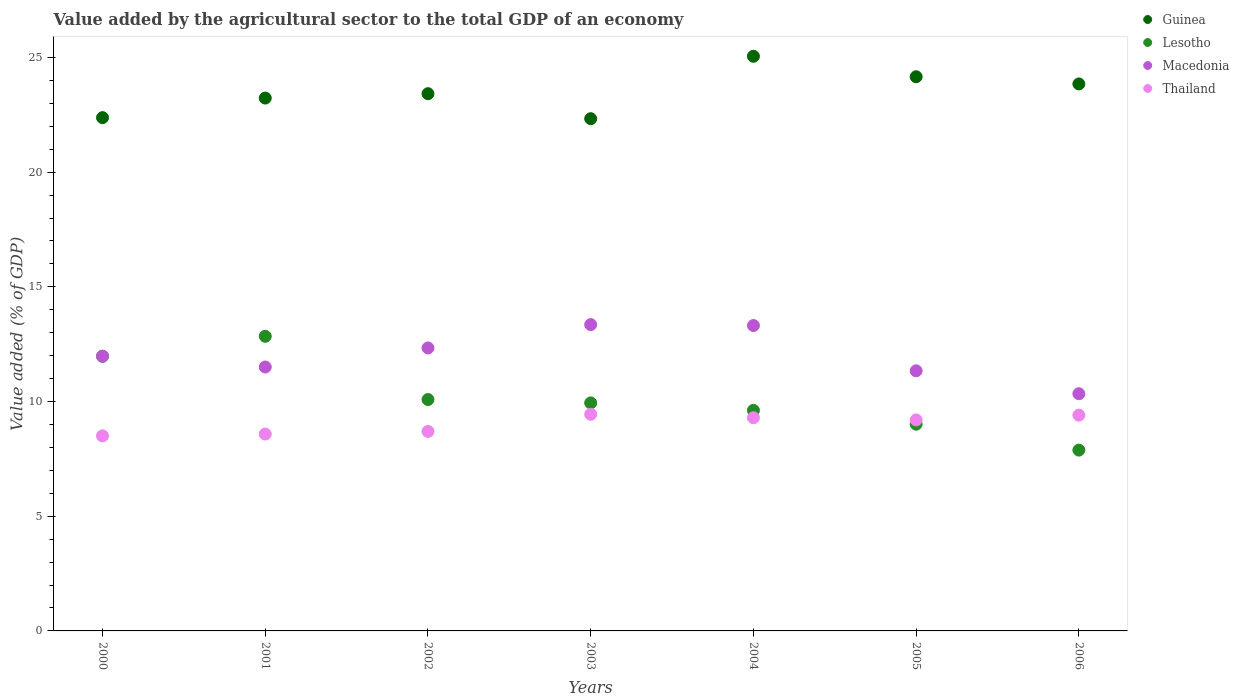What is the value added by the agricultural sector to the total GDP in Guinea in 2001?
Give a very brief answer. 23.23. Across all years, what is the maximum value added by the agricultural sector to the total GDP in Guinea?
Keep it short and to the point. 25.05. Across all years, what is the minimum value added by the agricultural sector to the total GDP in Thailand?
Keep it short and to the point. 8.5. In which year was the value added by the agricultural sector to the total GDP in Thailand maximum?
Provide a succinct answer. 2003. In which year was the value added by the agricultural sector to the total GDP in Macedonia minimum?
Keep it short and to the point. 2006. What is the total value added by the agricultural sector to the total GDP in Guinea in the graph?
Offer a terse response. 164.4. What is the difference between the value added by the agricultural sector to the total GDP in Macedonia in 2005 and that in 2006?
Your response must be concise. 1. What is the difference between the value added by the agricultural sector to the total GDP in Lesotho in 2006 and the value added by the agricultural sector to the total GDP in Macedonia in 2004?
Your answer should be compact. -5.43. What is the average value added by the agricultural sector to the total GDP in Lesotho per year?
Keep it short and to the point. 10.19. In the year 2000, what is the difference between the value added by the agricultural sector to the total GDP in Macedonia and value added by the agricultural sector to the total GDP in Thailand?
Ensure brevity in your answer.  3.47. In how many years, is the value added by the agricultural sector to the total GDP in Guinea greater than 2 %?
Your response must be concise. 7. What is the ratio of the value added by the agricultural sector to the total GDP in Thailand in 2002 to that in 2003?
Your response must be concise. 0.92. What is the difference between the highest and the second highest value added by the agricultural sector to the total GDP in Lesotho?
Make the answer very short. 0.87. What is the difference between the highest and the lowest value added by the agricultural sector to the total GDP in Lesotho?
Give a very brief answer. 4.96. Is the sum of the value added by the agricultural sector to the total GDP in Macedonia in 2001 and 2002 greater than the maximum value added by the agricultural sector to the total GDP in Guinea across all years?
Your answer should be compact. No. Is it the case that in every year, the sum of the value added by the agricultural sector to the total GDP in Macedonia and value added by the agricultural sector to the total GDP in Thailand  is greater than the sum of value added by the agricultural sector to the total GDP in Lesotho and value added by the agricultural sector to the total GDP in Guinea?
Make the answer very short. Yes. Is the value added by the agricultural sector to the total GDP in Macedonia strictly less than the value added by the agricultural sector to the total GDP in Guinea over the years?
Your answer should be very brief. Yes. How many dotlines are there?
Your answer should be very brief. 4. What is the difference between two consecutive major ticks on the Y-axis?
Give a very brief answer. 5. Does the graph contain any zero values?
Make the answer very short. No. Does the graph contain grids?
Give a very brief answer. No. Where does the legend appear in the graph?
Your answer should be very brief. Top right. How many legend labels are there?
Give a very brief answer. 4. What is the title of the graph?
Your answer should be very brief. Value added by the agricultural sector to the total GDP of an economy. Does "Ethiopia" appear as one of the legend labels in the graph?
Ensure brevity in your answer.  No. What is the label or title of the X-axis?
Offer a terse response. Years. What is the label or title of the Y-axis?
Give a very brief answer. Value added (% of GDP). What is the Value added (% of GDP) of Guinea in 2000?
Ensure brevity in your answer.  22.38. What is the Value added (% of GDP) of Lesotho in 2000?
Provide a succinct answer. 11.97. What is the Value added (% of GDP) of Macedonia in 2000?
Your answer should be very brief. 11.98. What is the Value added (% of GDP) of Thailand in 2000?
Provide a succinct answer. 8.5. What is the Value added (% of GDP) of Guinea in 2001?
Ensure brevity in your answer.  23.23. What is the Value added (% of GDP) in Lesotho in 2001?
Make the answer very short. 12.84. What is the Value added (% of GDP) in Macedonia in 2001?
Your response must be concise. 11.5. What is the Value added (% of GDP) of Thailand in 2001?
Ensure brevity in your answer.  8.58. What is the Value added (% of GDP) of Guinea in 2002?
Your answer should be compact. 23.42. What is the Value added (% of GDP) in Lesotho in 2002?
Your answer should be compact. 10.09. What is the Value added (% of GDP) in Macedonia in 2002?
Offer a terse response. 12.34. What is the Value added (% of GDP) in Thailand in 2002?
Offer a terse response. 8.7. What is the Value added (% of GDP) of Guinea in 2003?
Ensure brevity in your answer.  22.33. What is the Value added (% of GDP) in Lesotho in 2003?
Ensure brevity in your answer.  9.94. What is the Value added (% of GDP) of Macedonia in 2003?
Keep it short and to the point. 13.35. What is the Value added (% of GDP) in Thailand in 2003?
Provide a short and direct response. 9.44. What is the Value added (% of GDP) in Guinea in 2004?
Your answer should be very brief. 25.05. What is the Value added (% of GDP) of Lesotho in 2004?
Ensure brevity in your answer.  9.62. What is the Value added (% of GDP) in Macedonia in 2004?
Your answer should be compact. 13.31. What is the Value added (% of GDP) of Thailand in 2004?
Give a very brief answer. 9.29. What is the Value added (% of GDP) in Guinea in 2005?
Ensure brevity in your answer.  24.16. What is the Value added (% of GDP) of Lesotho in 2005?
Provide a short and direct response. 9.01. What is the Value added (% of GDP) in Macedonia in 2005?
Offer a very short reply. 11.34. What is the Value added (% of GDP) in Thailand in 2005?
Your answer should be very brief. 9.2. What is the Value added (% of GDP) in Guinea in 2006?
Offer a very short reply. 23.84. What is the Value added (% of GDP) of Lesotho in 2006?
Your response must be concise. 7.88. What is the Value added (% of GDP) in Macedonia in 2006?
Ensure brevity in your answer.  10.34. What is the Value added (% of GDP) of Thailand in 2006?
Keep it short and to the point. 9.41. Across all years, what is the maximum Value added (% of GDP) in Guinea?
Your answer should be compact. 25.05. Across all years, what is the maximum Value added (% of GDP) of Lesotho?
Give a very brief answer. 12.84. Across all years, what is the maximum Value added (% of GDP) in Macedonia?
Your answer should be very brief. 13.35. Across all years, what is the maximum Value added (% of GDP) in Thailand?
Your answer should be compact. 9.44. Across all years, what is the minimum Value added (% of GDP) in Guinea?
Your response must be concise. 22.33. Across all years, what is the minimum Value added (% of GDP) in Lesotho?
Your answer should be very brief. 7.88. Across all years, what is the minimum Value added (% of GDP) of Macedonia?
Make the answer very short. 10.34. Across all years, what is the minimum Value added (% of GDP) of Thailand?
Give a very brief answer. 8.5. What is the total Value added (% of GDP) of Guinea in the graph?
Keep it short and to the point. 164.4. What is the total Value added (% of GDP) in Lesotho in the graph?
Offer a terse response. 71.35. What is the total Value added (% of GDP) of Macedonia in the graph?
Your answer should be very brief. 84.16. What is the total Value added (% of GDP) in Thailand in the graph?
Your response must be concise. 63.12. What is the difference between the Value added (% of GDP) in Guinea in 2000 and that in 2001?
Your answer should be compact. -0.85. What is the difference between the Value added (% of GDP) of Lesotho in 2000 and that in 2001?
Your answer should be compact. -0.87. What is the difference between the Value added (% of GDP) in Macedonia in 2000 and that in 2001?
Your response must be concise. 0.47. What is the difference between the Value added (% of GDP) of Thailand in 2000 and that in 2001?
Provide a short and direct response. -0.08. What is the difference between the Value added (% of GDP) in Guinea in 2000 and that in 2002?
Give a very brief answer. -1.04. What is the difference between the Value added (% of GDP) of Lesotho in 2000 and that in 2002?
Provide a succinct answer. 1.88. What is the difference between the Value added (% of GDP) of Macedonia in 2000 and that in 2002?
Your response must be concise. -0.36. What is the difference between the Value added (% of GDP) in Thailand in 2000 and that in 2002?
Ensure brevity in your answer.  -0.19. What is the difference between the Value added (% of GDP) in Guinea in 2000 and that in 2003?
Make the answer very short. 0.05. What is the difference between the Value added (% of GDP) in Lesotho in 2000 and that in 2003?
Your response must be concise. 2.03. What is the difference between the Value added (% of GDP) in Macedonia in 2000 and that in 2003?
Offer a terse response. -1.38. What is the difference between the Value added (% of GDP) of Thailand in 2000 and that in 2003?
Ensure brevity in your answer.  -0.94. What is the difference between the Value added (% of GDP) in Guinea in 2000 and that in 2004?
Provide a succinct answer. -2.68. What is the difference between the Value added (% of GDP) in Lesotho in 2000 and that in 2004?
Make the answer very short. 2.35. What is the difference between the Value added (% of GDP) of Macedonia in 2000 and that in 2004?
Offer a very short reply. -1.34. What is the difference between the Value added (% of GDP) of Thailand in 2000 and that in 2004?
Keep it short and to the point. -0.79. What is the difference between the Value added (% of GDP) of Guinea in 2000 and that in 2005?
Your answer should be compact. -1.78. What is the difference between the Value added (% of GDP) in Lesotho in 2000 and that in 2005?
Provide a succinct answer. 2.96. What is the difference between the Value added (% of GDP) of Macedonia in 2000 and that in 2005?
Your answer should be compact. 0.64. What is the difference between the Value added (% of GDP) in Thailand in 2000 and that in 2005?
Provide a succinct answer. -0.7. What is the difference between the Value added (% of GDP) of Guinea in 2000 and that in 2006?
Offer a terse response. -1.47. What is the difference between the Value added (% of GDP) of Lesotho in 2000 and that in 2006?
Provide a short and direct response. 4.09. What is the difference between the Value added (% of GDP) of Macedonia in 2000 and that in 2006?
Your response must be concise. 1.64. What is the difference between the Value added (% of GDP) of Thailand in 2000 and that in 2006?
Offer a very short reply. -0.9. What is the difference between the Value added (% of GDP) of Guinea in 2001 and that in 2002?
Your response must be concise. -0.19. What is the difference between the Value added (% of GDP) of Lesotho in 2001 and that in 2002?
Keep it short and to the point. 2.76. What is the difference between the Value added (% of GDP) in Macedonia in 2001 and that in 2002?
Offer a terse response. -0.83. What is the difference between the Value added (% of GDP) of Thailand in 2001 and that in 2002?
Offer a very short reply. -0.11. What is the difference between the Value added (% of GDP) of Guinea in 2001 and that in 2003?
Your answer should be compact. 0.9. What is the difference between the Value added (% of GDP) in Lesotho in 2001 and that in 2003?
Your answer should be very brief. 2.9. What is the difference between the Value added (% of GDP) in Macedonia in 2001 and that in 2003?
Your answer should be compact. -1.85. What is the difference between the Value added (% of GDP) in Thailand in 2001 and that in 2003?
Your answer should be compact. -0.86. What is the difference between the Value added (% of GDP) of Guinea in 2001 and that in 2004?
Provide a succinct answer. -1.82. What is the difference between the Value added (% of GDP) of Lesotho in 2001 and that in 2004?
Ensure brevity in your answer.  3.23. What is the difference between the Value added (% of GDP) of Macedonia in 2001 and that in 2004?
Offer a terse response. -1.81. What is the difference between the Value added (% of GDP) in Thailand in 2001 and that in 2004?
Offer a terse response. -0.71. What is the difference between the Value added (% of GDP) in Guinea in 2001 and that in 2005?
Offer a terse response. -0.93. What is the difference between the Value added (% of GDP) in Lesotho in 2001 and that in 2005?
Your answer should be very brief. 3.83. What is the difference between the Value added (% of GDP) in Macedonia in 2001 and that in 2005?
Offer a very short reply. 0.17. What is the difference between the Value added (% of GDP) of Thailand in 2001 and that in 2005?
Provide a succinct answer. -0.62. What is the difference between the Value added (% of GDP) of Guinea in 2001 and that in 2006?
Provide a short and direct response. -0.62. What is the difference between the Value added (% of GDP) in Lesotho in 2001 and that in 2006?
Give a very brief answer. 4.96. What is the difference between the Value added (% of GDP) in Macedonia in 2001 and that in 2006?
Offer a very short reply. 1.16. What is the difference between the Value added (% of GDP) in Thailand in 2001 and that in 2006?
Ensure brevity in your answer.  -0.82. What is the difference between the Value added (% of GDP) in Guinea in 2002 and that in 2003?
Your response must be concise. 1.09. What is the difference between the Value added (% of GDP) in Lesotho in 2002 and that in 2003?
Give a very brief answer. 0.15. What is the difference between the Value added (% of GDP) in Macedonia in 2002 and that in 2003?
Your response must be concise. -1.02. What is the difference between the Value added (% of GDP) of Thailand in 2002 and that in 2003?
Give a very brief answer. -0.75. What is the difference between the Value added (% of GDP) in Guinea in 2002 and that in 2004?
Keep it short and to the point. -1.63. What is the difference between the Value added (% of GDP) in Lesotho in 2002 and that in 2004?
Give a very brief answer. 0.47. What is the difference between the Value added (% of GDP) in Macedonia in 2002 and that in 2004?
Offer a terse response. -0.98. What is the difference between the Value added (% of GDP) in Thailand in 2002 and that in 2004?
Provide a short and direct response. -0.6. What is the difference between the Value added (% of GDP) in Guinea in 2002 and that in 2005?
Provide a succinct answer. -0.74. What is the difference between the Value added (% of GDP) in Lesotho in 2002 and that in 2005?
Keep it short and to the point. 1.07. What is the difference between the Value added (% of GDP) of Macedonia in 2002 and that in 2005?
Your answer should be compact. 1. What is the difference between the Value added (% of GDP) of Thailand in 2002 and that in 2005?
Provide a succinct answer. -0.5. What is the difference between the Value added (% of GDP) in Guinea in 2002 and that in 2006?
Offer a terse response. -0.43. What is the difference between the Value added (% of GDP) in Lesotho in 2002 and that in 2006?
Your answer should be very brief. 2.2. What is the difference between the Value added (% of GDP) in Macedonia in 2002 and that in 2006?
Ensure brevity in your answer.  2. What is the difference between the Value added (% of GDP) in Thailand in 2002 and that in 2006?
Your response must be concise. -0.71. What is the difference between the Value added (% of GDP) of Guinea in 2003 and that in 2004?
Provide a short and direct response. -2.72. What is the difference between the Value added (% of GDP) of Lesotho in 2003 and that in 2004?
Provide a succinct answer. 0.32. What is the difference between the Value added (% of GDP) of Thailand in 2003 and that in 2004?
Give a very brief answer. 0.15. What is the difference between the Value added (% of GDP) in Guinea in 2003 and that in 2005?
Ensure brevity in your answer.  -1.83. What is the difference between the Value added (% of GDP) of Lesotho in 2003 and that in 2005?
Your answer should be compact. 0.93. What is the difference between the Value added (% of GDP) in Macedonia in 2003 and that in 2005?
Give a very brief answer. 2.01. What is the difference between the Value added (% of GDP) of Thailand in 2003 and that in 2005?
Your answer should be very brief. 0.25. What is the difference between the Value added (% of GDP) of Guinea in 2003 and that in 2006?
Your response must be concise. -1.52. What is the difference between the Value added (% of GDP) in Lesotho in 2003 and that in 2006?
Provide a succinct answer. 2.06. What is the difference between the Value added (% of GDP) in Macedonia in 2003 and that in 2006?
Offer a very short reply. 3.01. What is the difference between the Value added (% of GDP) in Thailand in 2003 and that in 2006?
Make the answer very short. 0.04. What is the difference between the Value added (% of GDP) in Guinea in 2004 and that in 2005?
Ensure brevity in your answer.  0.89. What is the difference between the Value added (% of GDP) in Lesotho in 2004 and that in 2005?
Your answer should be very brief. 0.6. What is the difference between the Value added (% of GDP) in Macedonia in 2004 and that in 2005?
Offer a terse response. 1.97. What is the difference between the Value added (% of GDP) in Thailand in 2004 and that in 2005?
Your answer should be very brief. 0.1. What is the difference between the Value added (% of GDP) in Guinea in 2004 and that in 2006?
Ensure brevity in your answer.  1.21. What is the difference between the Value added (% of GDP) in Lesotho in 2004 and that in 2006?
Provide a short and direct response. 1.73. What is the difference between the Value added (% of GDP) of Macedonia in 2004 and that in 2006?
Give a very brief answer. 2.97. What is the difference between the Value added (% of GDP) in Thailand in 2004 and that in 2006?
Your answer should be compact. -0.11. What is the difference between the Value added (% of GDP) in Guinea in 2005 and that in 2006?
Give a very brief answer. 0.31. What is the difference between the Value added (% of GDP) in Lesotho in 2005 and that in 2006?
Offer a terse response. 1.13. What is the difference between the Value added (% of GDP) of Macedonia in 2005 and that in 2006?
Offer a terse response. 1. What is the difference between the Value added (% of GDP) of Thailand in 2005 and that in 2006?
Provide a succinct answer. -0.21. What is the difference between the Value added (% of GDP) of Guinea in 2000 and the Value added (% of GDP) of Lesotho in 2001?
Ensure brevity in your answer.  9.53. What is the difference between the Value added (% of GDP) of Guinea in 2000 and the Value added (% of GDP) of Macedonia in 2001?
Ensure brevity in your answer.  10.87. What is the difference between the Value added (% of GDP) of Guinea in 2000 and the Value added (% of GDP) of Thailand in 2001?
Make the answer very short. 13.79. What is the difference between the Value added (% of GDP) of Lesotho in 2000 and the Value added (% of GDP) of Macedonia in 2001?
Your answer should be compact. 0.47. What is the difference between the Value added (% of GDP) in Lesotho in 2000 and the Value added (% of GDP) in Thailand in 2001?
Your response must be concise. 3.39. What is the difference between the Value added (% of GDP) in Macedonia in 2000 and the Value added (% of GDP) in Thailand in 2001?
Ensure brevity in your answer.  3.4. What is the difference between the Value added (% of GDP) in Guinea in 2000 and the Value added (% of GDP) in Lesotho in 2002?
Your answer should be compact. 12.29. What is the difference between the Value added (% of GDP) of Guinea in 2000 and the Value added (% of GDP) of Macedonia in 2002?
Ensure brevity in your answer.  10.04. What is the difference between the Value added (% of GDP) of Guinea in 2000 and the Value added (% of GDP) of Thailand in 2002?
Your response must be concise. 13.68. What is the difference between the Value added (% of GDP) in Lesotho in 2000 and the Value added (% of GDP) in Macedonia in 2002?
Ensure brevity in your answer.  -0.37. What is the difference between the Value added (% of GDP) in Lesotho in 2000 and the Value added (% of GDP) in Thailand in 2002?
Provide a short and direct response. 3.27. What is the difference between the Value added (% of GDP) in Macedonia in 2000 and the Value added (% of GDP) in Thailand in 2002?
Provide a short and direct response. 3.28. What is the difference between the Value added (% of GDP) of Guinea in 2000 and the Value added (% of GDP) of Lesotho in 2003?
Your response must be concise. 12.44. What is the difference between the Value added (% of GDP) in Guinea in 2000 and the Value added (% of GDP) in Macedonia in 2003?
Provide a short and direct response. 9.02. What is the difference between the Value added (% of GDP) of Guinea in 2000 and the Value added (% of GDP) of Thailand in 2003?
Give a very brief answer. 12.93. What is the difference between the Value added (% of GDP) of Lesotho in 2000 and the Value added (% of GDP) of Macedonia in 2003?
Make the answer very short. -1.38. What is the difference between the Value added (% of GDP) of Lesotho in 2000 and the Value added (% of GDP) of Thailand in 2003?
Provide a succinct answer. 2.53. What is the difference between the Value added (% of GDP) in Macedonia in 2000 and the Value added (% of GDP) in Thailand in 2003?
Provide a succinct answer. 2.53. What is the difference between the Value added (% of GDP) in Guinea in 2000 and the Value added (% of GDP) in Lesotho in 2004?
Your answer should be very brief. 12.76. What is the difference between the Value added (% of GDP) of Guinea in 2000 and the Value added (% of GDP) of Macedonia in 2004?
Offer a terse response. 9.06. What is the difference between the Value added (% of GDP) in Guinea in 2000 and the Value added (% of GDP) in Thailand in 2004?
Your answer should be very brief. 13.08. What is the difference between the Value added (% of GDP) of Lesotho in 2000 and the Value added (% of GDP) of Macedonia in 2004?
Provide a short and direct response. -1.34. What is the difference between the Value added (% of GDP) of Lesotho in 2000 and the Value added (% of GDP) of Thailand in 2004?
Make the answer very short. 2.68. What is the difference between the Value added (% of GDP) in Macedonia in 2000 and the Value added (% of GDP) in Thailand in 2004?
Provide a short and direct response. 2.68. What is the difference between the Value added (% of GDP) in Guinea in 2000 and the Value added (% of GDP) in Lesotho in 2005?
Keep it short and to the point. 13.36. What is the difference between the Value added (% of GDP) in Guinea in 2000 and the Value added (% of GDP) in Macedonia in 2005?
Offer a terse response. 11.04. What is the difference between the Value added (% of GDP) of Guinea in 2000 and the Value added (% of GDP) of Thailand in 2005?
Provide a succinct answer. 13.18. What is the difference between the Value added (% of GDP) of Lesotho in 2000 and the Value added (% of GDP) of Macedonia in 2005?
Your answer should be compact. 0.63. What is the difference between the Value added (% of GDP) in Lesotho in 2000 and the Value added (% of GDP) in Thailand in 2005?
Your response must be concise. 2.77. What is the difference between the Value added (% of GDP) in Macedonia in 2000 and the Value added (% of GDP) in Thailand in 2005?
Ensure brevity in your answer.  2.78. What is the difference between the Value added (% of GDP) in Guinea in 2000 and the Value added (% of GDP) in Lesotho in 2006?
Provide a short and direct response. 14.49. What is the difference between the Value added (% of GDP) in Guinea in 2000 and the Value added (% of GDP) in Macedonia in 2006?
Offer a terse response. 12.04. What is the difference between the Value added (% of GDP) in Guinea in 2000 and the Value added (% of GDP) in Thailand in 2006?
Your response must be concise. 12.97. What is the difference between the Value added (% of GDP) in Lesotho in 2000 and the Value added (% of GDP) in Macedonia in 2006?
Provide a succinct answer. 1.63. What is the difference between the Value added (% of GDP) of Lesotho in 2000 and the Value added (% of GDP) of Thailand in 2006?
Keep it short and to the point. 2.56. What is the difference between the Value added (% of GDP) in Macedonia in 2000 and the Value added (% of GDP) in Thailand in 2006?
Keep it short and to the point. 2.57. What is the difference between the Value added (% of GDP) of Guinea in 2001 and the Value added (% of GDP) of Lesotho in 2002?
Keep it short and to the point. 13.14. What is the difference between the Value added (% of GDP) in Guinea in 2001 and the Value added (% of GDP) in Macedonia in 2002?
Make the answer very short. 10.89. What is the difference between the Value added (% of GDP) in Guinea in 2001 and the Value added (% of GDP) in Thailand in 2002?
Your answer should be very brief. 14.53. What is the difference between the Value added (% of GDP) in Lesotho in 2001 and the Value added (% of GDP) in Macedonia in 2002?
Keep it short and to the point. 0.51. What is the difference between the Value added (% of GDP) in Lesotho in 2001 and the Value added (% of GDP) in Thailand in 2002?
Offer a very short reply. 4.15. What is the difference between the Value added (% of GDP) of Macedonia in 2001 and the Value added (% of GDP) of Thailand in 2002?
Keep it short and to the point. 2.81. What is the difference between the Value added (% of GDP) in Guinea in 2001 and the Value added (% of GDP) in Lesotho in 2003?
Offer a terse response. 13.29. What is the difference between the Value added (% of GDP) in Guinea in 2001 and the Value added (% of GDP) in Macedonia in 2003?
Give a very brief answer. 9.88. What is the difference between the Value added (% of GDP) in Guinea in 2001 and the Value added (% of GDP) in Thailand in 2003?
Offer a very short reply. 13.78. What is the difference between the Value added (% of GDP) in Lesotho in 2001 and the Value added (% of GDP) in Macedonia in 2003?
Your answer should be very brief. -0.51. What is the difference between the Value added (% of GDP) in Lesotho in 2001 and the Value added (% of GDP) in Thailand in 2003?
Provide a succinct answer. 3.4. What is the difference between the Value added (% of GDP) in Macedonia in 2001 and the Value added (% of GDP) in Thailand in 2003?
Ensure brevity in your answer.  2.06. What is the difference between the Value added (% of GDP) of Guinea in 2001 and the Value added (% of GDP) of Lesotho in 2004?
Provide a succinct answer. 13.61. What is the difference between the Value added (% of GDP) in Guinea in 2001 and the Value added (% of GDP) in Macedonia in 2004?
Keep it short and to the point. 9.92. What is the difference between the Value added (% of GDP) in Guinea in 2001 and the Value added (% of GDP) in Thailand in 2004?
Your answer should be very brief. 13.93. What is the difference between the Value added (% of GDP) of Lesotho in 2001 and the Value added (% of GDP) of Macedonia in 2004?
Make the answer very short. -0.47. What is the difference between the Value added (% of GDP) of Lesotho in 2001 and the Value added (% of GDP) of Thailand in 2004?
Offer a terse response. 3.55. What is the difference between the Value added (% of GDP) in Macedonia in 2001 and the Value added (% of GDP) in Thailand in 2004?
Provide a succinct answer. 2.21. What is the difference between the Value added (% of GDP) of Guinea in 2001 and the Value added (% of GDP) of Lesotho in 2005?
Make the answer very short. 14.22. What is the difference between the Value added (% of GDP) of Guinea in 2001 and the Value added (% of GDP) of Macedonia in 2005?
Provide a succinct answer. 11.89. What is the difference between the Value added (% of GDP) of Guinea in 2001 and the Value added (% of GDP) of Thailand in 2005?
Your answer should be compact. 14.03. What is the difference between the Value added (% of GDP) of Lesotho in 2001 and the Value added (% of GDP) of Macedonia in 2005?
Make the answer very short. 1.5. What is the difference between the Value added (% of GDP) of Lesotho in 2001 and the Value added (% of GDP) of Thailand in 2005?
Provide a succinct answer. 3.65. What is the difference between the Value added (% of GDP) in Macedonia in 2001 and the Value added (% of GDP) in Thailand in 2005?
Give a very brief answer. 2.31. What is the difference between the Value added (% of GDP) in Guinea in 2001 and the Value added (% of GDP) in Lesotho in 2006?
Provide a short and direct response. 15.35. What is the difference between the Value added (% of GDP) in Guinea in 2001 and the Value added (% of GDP) in Macedonia in 2006?
Ensure brevity in your answer.  12.89. What is the difference between the Value added (% of GDP) of Guinea in 2001 and the Value added (% of GDP) of Thailand in 2006?
Keep it short and to the point. 13.82. What is the difference between the Value added (% of GDP) of Lesotho in 2001 and the Value added (% of GDP) of Macedonia in 2006?
Offer a very short reply. 2.5. What is the difference between the Value added (% of GDP) of Lesotho in 2001 and the Value added (% of GDP) of Thailand in 2006?
Ensure brevity in your answer.  3.44. What is the difference between the Value added (% of GDP) in Macedonia in 2001 and the Value added (% of GDP) in Thailand in 2006?
Give a very brief answer. 2.1. What is the difference between the Value added (% of GDP) of Guinea in 2002 and the Value added (% of GDP) of Lesotho in 2003?
Offer a very short reply. 13.48. What is the difference between the Value added (% of GDP) of Guinea in 2002 and the Value added (% of GDP) of Macedonia in 2003?
Give a very brief answer. 10.07. What is the difference between the Value added (% of GDP) of Guinea in 2002 and the Value added (% of GDP) of Thailand in 2003?
Offer a terse response. 13.97. What is the difference between the Value added (% of GDP) of Lesotho in 2002 and the Value added (% of GDP) of Macedonia in 2003?
Make the answer very short. -3.27. What is the difference between the Value added (% of GDP) of Lesotho in 2002 and the Value added (% of GDP) of Thailand in 2003?
Provide a short and direct response. 0.64. What is the difference between the Value added (% of GDP) of Macedonia in 2002 and the Value added (% of GDP) of Thailand in 2003?
Provide a short and direct response. 2.89. What is the difference between the Value added (% of GDP) of Guinea in 2002 and the Value added (% of GDP) of Lesotho in 2004?
Your answer should be compact. 13.8. What is the difference between the Value added (% of GDP) in Guinea in 2002 and the Value added (% of GDP) in Macedonia in 2004?
Make the answer very short. 10.11. What is the difference between the Value added (% of GDP) of Guinea in 2002 and the Value added (% of GDP) of Thailand in 2004?
Provide a succinct answer. 14.12. What is the difference between the Value added (% of GDP) of Lesotho in 2002 and the Value added (% of GDP) of Macedonia in 2004?
Make the answer very short. -3.23. What is the difference between the Value added (% of GDP) in Lesotho in 2002 and the Value added (% of GDP) in Thailand in 2004?
Make the answer very short. 0.79. What is the difference between the Value added (% of GDP) of Macedonia in 2002 and the Value added (% of GDP) of Thailand in 2004?
Make the answer very short. 3.04. What is the difference between the Value added (% of GDP) of Guinea in 2002 and the Value added (% of GDP) of Lesotho in 2005?
Keep it short and to the point. 14.41. What is the difference between the Value added (% of GDP) of Guinea in 2002 and the Value added (% of GDP) of Macedonia in 2005?
Your answer should be compact. 12.08. What is the difference between the Value added (% of GDP) of Guinea in 2002 and the Value added (% of GDP) of Thailand in 2005?
Your response must be concise. 14.22. What is the difference between the Value added (% of GDP) of Lesotho in 2002 and the Value added (% of GDP) of Macedonia in 2005?
Keep it short and to the point. -1.25. What is the difference between the Value added (% of GDP) in Lesotho in 2002 and the Value added (% of GDP) in Thailand in 2005?
Make the answer very short. 0.89. What is the difference between the Value added (% of GDP) in Macedonia in 2002 and the Value added (% of GDP) in Thailand in 2005?
Your answer should be very brief. 3.14. What is the difference between the Value added (% of GDP) in Guinea in 2002 and the Value added (% of GDP) in Lesotho in 2006?
Offer a very short reply. 15.54. What is the difference between the Value added (% of GDP) in Guinea in 2002 and the Value added (% of GDP) in Macedonia in 2006?
Ensure brevity in your answer.  13.08. What is the difference between the Value added (% of GDP) of Guinea in 2002 and the Value added (% of GDP) of Thailand in 2006?
Offer a terse response. 14.01. What is the difference between the Value added (% of GDP) of Lesotho in 2002 and the Value added (% of GDP) of Macedonia in 2006?
Your answer should be very brief. -0.25. What is the difference between the Value added (% of GDP) in Lesotho in 2002 and the Value added (% of GDP) in Thailand in 2006?
Provide a short and direct response. 0.68. What is the difference between the Value added (% of GDP) of Macedonia in 2002 and the Value added (% of GDP) of Thailand in 2006?
Make the answer very short. 2.93. What is the difference between the Value added (% of GDP) of Guinea in 2003 and the Value added (% of GDP) of Lesotho in 2004?
Provide a short and direct response. 12.71. What is the difference between the Value added (% of GDP) in Guinea in 2003 and the Value added (% of GDP) in Macedonia in 2004?
Give a very brief answer. 9.02. What is the difference between the Value added (% of GDP) in Guinea in 2003 and the Value added (% of GDP) in Thailand in 2004?
Make the answer very short. 13.03. What is the difference between the Value added (% of GDP) of Lesotho in 2003 and the Value added (% of GDP) of Macedonia in 2004?
Your response must be concise. -3.37. What is the difference between the Value added (% of GDP) of Lesotho in 2003 and the Value added (% of GDP) of Thailand in 2004?
Provide a succinct answer. 0.65. What is the difference between the Value added (% of GDP) in Macedonia in 2003 and the Value added (% of GDP) in Thailand in 2004?
Your response must be concise. 4.06. What is the difference between the Value added (% of GDP) in Guinea in 2003 and the Value added (% of GDP) in Lesotho in 2005?
Your answer should be compact. 13.32. What is the difference between the Value added (% of GDP) in Guinea in 2003 and the Value added (% of GDP) in Macedonia in 2005?
Your answer should be compact. 10.99. What is the difference between the Value added (% of GDP) in Guinea in 2003 and the Value added (% of GDP) in Thailand in 2005?
Ensure brevity in your answer.  13.13. What is the difference between the Value added (% of GDP) in Lesotho in 2003 and the Value added (% of GDP) in Macedonia in 2005?
Your answer should be compact. -1.4. What is the difference between the Value added (% of GDP) in Lesotho in 2003 and the Value added (% of GDP) in Thailand in 2005?
Give a very brief answer. 0.74. What is the difference between the Value added (% of GDP) in Macedonia in 2003 and the Value added (% of GDP) in Thailand in 2005?
Your response must be concise. 4.16. What is the difference between the Value added (% of GDP) in Guinea in 2003 and the Value added (% of GDP) in Lesotho in 2006?
Make the answer very short. 14.45. What is the difference between the Value added (% of GDP) of Guinea in 2003 and the Value added (% of GDP) of Macedonia in 2006?
Your response must be concise. 11.99. What is the difference between the Value added (% of GDP) in Guinea in 2003 and the Value added (% of GDP) in Thailand in 2006?
Keep it short and to the point. 12.92. What is the difference between the Value added (% of GDP) of Lesotho in 2003 and the Value added (% of GDP) of Macedonia in 2006?
Your answer should be very brief. -0.4. What is the difference between the Value added (% of GDP) in Lesotho in 2003 and the Value added (% of GDP) in Thailand in 2006?
Provide a short and direct response. 0.53. What is the difference between the Value added (% of GDP) of Macedonia in 2003 and the Value added (% of GDP) of Thailand in 2006?
Your answer should be compact. 3.95. What is the difference between the Value added (% of GDP) of Guinea in 2004 and the Value added (% of GDP) of Lesotho in 2005?
Ensure brevity in your answer.  16.04. What is the difference between the Value added (% of GDP) in Guinea in 2004 and the Value added (% of GDP) in Macedonia in 2005?
Make the answer very short. 13.71. What is the difference between the Value added (% of GDP) in Guinea in 2004 and the Value added (% of GDP) in Thailand in 2005?
Your response must be concise. 15.85. What is the difference between the Value added (% of GDP) of Lesotho in 2004 and the Value added (% of GDP) of Macedonia in 2005?
Provide a short and direct response. -1.72. What is the difference between the Value added (% of GDP) in Lesotho in 2004 and the Value added (% of GDP) in Thailand in 2005?
Offer a very short reply. 0.42. What is the difference between the Value added (% of GDP) in Macedonia in 2004 and the Value added (% of GDP) in Thailand in 2005?
Make the answer very short. 4.12. What is the difference between the Value added (% of GDP) of Guinea in 2004 and the Value added (% of GDP) of Lesotho in 2006?
Offer a terse response. 17.17. What is the difference between the Value added (% of GDP) of Guinea in 2004 and the Value added (% of GDP) of Macedonia in 2006?
Your answer should be compact. 14.71. What is the difference between the Value added (% of GDP) of Guinea in 2004 and the Value added (% of GDP) of Thailand in 2006?
Offer a very short reply. 15.64. What is the difference between the Value added (% of GDP) of Lesotho in 2004 and the Value added (% of GDP) of Macedonia in 2006?
Provide a succinct answer. -0.72. What is the difference between the Value added (% of GDP) in Lesotho in 2004 and the Value added (% of GDP) in Thailand in 2006?
Give a very brief answer. 0.21. What is the difference between the Value added (% of GDP) in Macedonia in 2004 and the Value added (% of GDP) in Thailand in 2006?
Offer a terse response. 3.91. What is the difference between the Value added (% of GDP) of Guinea in 2005 and the Value added (% of GDP) of Lesotho in 2006?
Your answer should be compact. 16.28. What is the difference between the Value added (% of GDP) of Guinea in 2005 and the Value added (% of GDP) of Macedonia in 2006?
Make the answer very short. 13.82. What is the difference between the Value added (% of GDP) of Guinea in 2005 and the Value added (% of GDP) of Thailand in 2006?
Make the answer very short. 14.75. What is the difference between the Value added (% of GDP) in Lesotho in 2005 and the Value added (% of GDP) in Macedonia in 2006?
Make the answer very short. -1.33. What is the difference between the Value added (% of GDP) in Lesotho in 2005 and the Value added (% of GDP) in Thailand in 2006?
Ensure brevity in your answer.  -0.39. What is the difference between the Value added (% of GDP) of Macedonia in 2005 and the Value added (% of GDP) of Thailand in 2006?
Provide a succinct answer. 1.93. What is the average Value added (% of GDP) in Guinea per year?
Make the answer very short. 23.49. What is the average Value added (% of GDP) of Lesotho per year?
Offer a terse response. 10.19. What is the average Value added (% of GDP) in Macedonia per year?
Your answer should be very brief. 12.02. What is the average Value added (% of GDP) of Thailand per year?
Your answer should be compact. 9.02. In the year 2000, what is the difference between the Value added (% of GDP) of Guinea and Value added (% of GDP) of Lesotho?
Your response must be concise. 10.41. In the year 2000, what is the difference between the Value added (% of GDP) in Guinea and Value added (% of GDP) in Macedonia?
Your answer should be very brief. 10.4. In the year 2000, what is the difference between the Value added (% of GDP) of Guinea and Value added (% of GDP) of Thailand?
Make the answer very short. 13.87. In the year 2000, what is the difference between the Value added (% of GDP) in Lesotho and Value added (% of GDP) in Macedonia?
Provide a short and direct response. -0.01. In the year 2000, what is the difference between the Value added (% of GDP) of Lesotho and Value added (% of GDP) of Thailand?
Provide a short and direct response. 3.47. In the year 2000, what is the difference between the Value added (% of GDP) of Macedonia and Value added (% of GDP) of Thailand?
Your response must be concise. 3.47. In the year 2001, what is the difference between the Value added (% of GDP) of Guinea and Value added (% of GDP) of Lesotho?
Give a very brief answer. 10.38. In the year 2001, what is the difference between the Value added (% of GDP) of Guinea and Value added (% of GDP) of Macedonia?
Your answer should be very brief. 11.72. In the year 2001, what is the difference between the Value added (% of GDP) of Guinea and Value added (% of GDP) of Thailand?
Offer a terse response. 14.65. In the year 2001, what is the difference between the Value added (% of GDP) of Lesotho and Value added (% of GDP) of Macedonia?
Your answer should be compact. 1.34. In the year 2001, what is the difference between the Value added (% of GDP) of Lesotho and Value added (% of GDP) of Thailand?
Keep it short and to the point. 4.26. In the year 2001, what is the difference between the Value added (% of GDP) in Macedonia and Value added (% of GDP) in Thailand?
Your answer should be very brief. 2.92. In the year 2002, what is the difference between the Value added (% of GDP) of Guinea and Value added (% of GDP) of Lesotho?
Ensure brevity in your answer.  13.33. In the year 2002, what is the difference between the Value added (% of GDP) of Guinea and Value added (% of GDP) of Macedonia?
Provide a short and direct response. 11.08. In the year 2002, what is the difference between the Value added (% of GDP) of Guinea and Value added (% of GDP) of Thailand?
Keep it short and to the point. 14.72. In the year 2002, what is the difference between the Value added (% of GDP) in Lesotho and Value added (% of GDP) in Macedonia?
Your answer should be very brief. -2.25. In the year 2002, what is the difference between the Value added (% of GDP) in Lesotho and Value added (% of GDP) in Thailand?
Your response must be concise. 1.39. In the year 2002, what is the difference between the Value added (% of GDP) in Macedonia and Value added (% of GDP) in Thailand?
Your answer should be very brief. 3.64. In the year 2003, what is the difference between the Value added (% of GDP) of Guinea and Value added (% of GDP) of Lesotho?
Keep it short and to the point. 12.39. In the year 2003, what is the difference between the Value added (% of GDP) in Guinea and Value added (% of GDP) in Macedonia?
Keep it short and to the point. 8.98. In the year 2003, what is the difference between the Value added (% of GDP) of Guinea and Value added (% of GDP) of Thailand?
Provide a succinct answer. 12.88. In the year 2003, what is the difference between the Value added (% of GDP) of Lesotho and Value added (% of GDP) of Macedonia?
Your response must be concise. -3.41. In the year 2003, what is the difference between the Value added (% of GDP) of Lesotho and Value added (% of GDP) of Thailand?
Make the answer very short. 0.5. In the year 2003, what is the difference between the Value added (% of GDP) of Macedonia and Value added (% of GDP) of Thailand?
Offer a very short reply. 3.91. In the year 2004, what is the difference between the Value added (% of GDP) in Guinea and Value added (% of GDP) in Lesotho?
Provide a short and direct response. 15.44. In the year 2004, what is the difference between the Value added (% of GDP) in Guinea and Value added (% of GDP) in Macedonia?
Provide a succinct answer. 11.74. In the year 2004, what is the difference between the Value added (% of GDP) of Guinea and Value added (% of GDP) of Thailand?
Offer a very short reply. 15.76. In the year 2004, what is the difference between the Value added (% of GDP) of Lesotho and Value added (% of GDP) of Macedonia?
Your response must be concise. -3.7. In the year 2004, what is the difference between the Value added (% of GDP) in Lesotho and Value added (% of GDP) in Thailand?
Your response must be concise. 0.32. In the year 2004, what is the difference between the Value added (% of GDP) of Macedonia and Value added (% of GDP) of Thailand?
Ensure brevity in your answer.  4.02. In the year 2005, what is the difference between the Value added (% of GDP) of Guinea and Value added (% of GDP) of Lesotho?
Ensure brevity in your answer.  15.15. In the year 2005, what is the difference between the Value added (% of GDP) of Guinea and Value added (% of GDP) of Macedonia?
Offer a terse response. 12.82. In the year 2005, what is the difference between the Value added (% of GDP) in Guinea and Value added (% of GDP) in Thailand?
Your response must be concise. 14.96. In the year 2005, what is the difference between the Value added (% of GDP) in Lesotho and Value added (% of GDP) in Macedonia?
Your answer should be very brief. -2.33. In the year 2005, what is the difference between the Value added (% of GDP) of Lesotho and Value added (% of GDP) of Thailand?
Keep it short and to the point. -0.19. In the year 2005, what is the difference between the Value added (% of GDP) in Macedonia and Value added (% of GDP) in Thailand?
Your response must be concise. 2.14. In the year 2006, what is the difference between the Value added (% of GDP) of Guinea and Value added (% of GDP) of Lesotho?
Keep it short and to the point. 15.96. In the year 2006, what is the difference between the Value added (% of GDP) of Guinea and Value added (% of GDP) of Macedonia?
Keep it short and to the point. 13.5. In the year 2006, what is the difference between the Value added (% of GDP) of Guinea and Value added (% of GDP) of Thailand?
Give a very brief answer. 14.44. In the year 2006, what is the difference between the Value added (% of GDP) in Lesotho and Value added (% of GDP) in Macedonia?
Your answer should be compact. -2.46. In the year 2006, what is the difference between the Value added (% of GDP) of Lesotho and Value added (% of GDP) of Thailand?
Ensure brevity in your answer.  -1.52. In the year 2006, what is the difference between the Value added (% of GDP) of Macedonia and Value added (% of GDP) of Thailand?
Provide a short and direct response. 0.93. What is the ratio of the Value added (% of GDP) in Guinea in 2000 to that in 2001?
Provide a short and direct response. 0.96. What is the ratio of the Value added (% of GDP) in Lesotho in 2000 to that in 2001?
Provide a short and direct response. 0.93. What is the ratio of the Value added (% of GDP) in Macedonia in 2000 to that in 2001?
Provide a succinct answer. 1.04. What is the ratio of the Value added (% of GDP) of Thailand in 2000 to that in 2001?
Offer a terse response. 0.99. What is the ratio of the Value added (% of GDP) of Guinea in 2000 to that in 2002?
Offer a terse response. 0.96. What is the ratio of the Value added (% of GDP) of Lesotho in 2000 to that in 2002?
Ensure brevity in your answer.  1.19. What is the ratio of the Value added (% of GDP) of Thailand in 2000 to that in 2002?
Provide a succinct answer. 0.98. What is the ratio of the Value added (% of GDP) of Lesotho in 2000 to that in 2003?
Give a very brief answer. 1.2. What is the ratio of the Value added (% of GDP) in Macedonia in 2000 to that in 2003?
Offer a terse response. 0.9. What is the ratio of the Value added (% of GDP) of Thailand in 2000 to that in 2003?
Offer a terse response. 0.9. What is the ratio of the Value added (% of GDP) in Guinea in 2000 to that in 2004?
Your answer should be very brief. 0.89. What is the ratio of the Value added (% of GDP) of Lesotho in 2000 to that in 2004?
Your answer should be very brief. 1.24. What is the ratio of the Value added (% of GDP) of Macedonia in 2000 to that in 2004?
Offer a terse response. 0.9. What is the ratio of the Value added (% of GDP) in Thailand in 2000 to that in 2004?
Ensure brevity in your answer.  0.91. What is the ratio of the Value added (% of GDP) in Guinea in 2000 to that in 2005?
Your response must be concise. 0.93. What is the ratio of the Value added (% of GDP) in Lesotho in 2000 to that in 2005?
Give a very brief answer. 1.33. What is the ratio of the Value added (% of GDP) of Macedonia in 2000 to that in 2005?
Your response must be concise. 1.06. What is the ratio of the Value added (% of GDP) in Thailand in 2000 to that in 2005?
Your answer should be very brief. 0.92. What is the ratio of the Value added (% of GDP) in Guinea in 2000 to that in 2006?
Ensure brevity in your answer.  0.94. What is the ratio of the Value added (% of GDP) in Lesotho in 2000 to that in 2006?
Your answer should be very brief. 1.52. What is the ratio of the Value added (% of GDP) in Macedonia in 2000 to that in 2006?
Your answer should be compact. 1.16. What is the ratio of the Value added (% of GDP) in Thailand in 2000 to that in 2006?
Make the answer very short. 0.9. What is the ratio of the Value added (% of GDP) of Lesotho in 2001 to that in 2002?
Provide a short and direct response. 1.27. What is the ratio of the Value added (% of GDP) in Macedonia in 2001 to that in 2002?
Your answer should be very brief. 0.93. What is the ratio of the Value added (% of GDP) in Thailand in 2001 to that in 2002?
Keep it short and to the point. 0.99. What is the ratio of the Value added (% of GDP) of Guinea in 2001 to that in 2003?
Your response must be concise. 1.04. What is the ratio of the Value added (% of GDP) in Lesotho in 2001 to that in 2003?
Keep it short and to the point. 1.29. What is the ratio of the Value added (% of GDP) in Macedonia in 2001 to that in 2003?
Keep it short and to the point. 0.86. What is the ratio of the Value added (% of GDP) in Thailand in 2001 to that in 2003?
Make the answer very short. 0.91. What is the ratio of the Value added (% of GDP) in Guinea in 2001 to that in 2004?
Give a very brief answer. 0.93. What is the ratio of the Value added (% of GDP) in Lesotho in 2001 to that in 2004?
Your answer should be compact. 1.34. What is the ratio of the Value added (% of GDP) in Macedonia in 2001 to that in 2004?
Provide a succinct answer. 0.86. What is the ratio of the Value added (% of GDP) of Thailand in 2001 to that in 2004?
Ensure brevity in your answer.  0.92. What is the ratio of the Value added (% of GDP) of Guinea in 2001 to that in 2005?
Make the answer very short. 0.96. What is the ratio of the Value added (% of GDP) of Lesotho in 2001 to that in 2005?
Give a very brief answer. 1.43. What is the ratio of the Value added (% of GDP) in Macedonia in 2001 to that in 2005?
Your answer should be compact. 1.01. What is the ratio of the Value added (% of GDP) of Thailand in 2001 to that in 2005?
Give a very brief answer. 0.93. What is the ratio of the Value added (% of GDP) in Guinea in 2001 to that in 2006?
Your response must be concise. 0.97. What is the ratio of the Value added (% of GDP) in Lesotho in 2001 to that in 2006?
Provide a succinct answer. 1.63. What is the ratio of the Value added (% of GDP) of Macedonia in 2001 to that in 2006?
Your answer should be compact. 1.11. What is the ratio of the Value added (% of GDP) of Thailand in 2001 to that in 2006?
Your answer should be compact. 0.91. What is the ratio of the Value added (% of GDP) of Guinea in 2002 to that in 2003?
Keep it short and to the point. 1.05. What is the ratio of the Value added (% of GDP) of Lesotho in 2002 to that in 2003?
Your answer should be compact. 1.01. What is the ratio of the Value added (% of GDP) of Macedonia in 2002 to that in 2003?
Offer a terse response. 0.92. What is the ratio of the Value added (% of GDP) in Thailand in 2002 to that in 2003?
Keep it short and to the point. 0.92. What is the ratio of the Value added (% of GDP) of Guinea in 2002 to that in 2004?
Your answer should be compact. 0.93. What is the ratio of the Value added (% of GDP) of Lesotho in 2002 to that in 2004?
Make the answer very short. 1.05. What is the ratio of the Value added (% of GDP) in Macedonia in 2002 to that in 2004?
Your answer should be very brief. 0.93. What is the ratio of the Value added (% of GDP) of Thailand in 2002 to that in 2004?
Provide a short and direct response. 0.94. What is the ratio of the Value added (% of GDP) of Guinea in 2002 to that in 2005?
Your answer should be very brief. 0.97. What is the ratio of the Value added (% of GDP) in Lesotho in 2002 to that in 2005?
Keep it short and to the point. 1.12. What is the ratio of the Value added (% of GDP) of Macedonia in 2002 to that in 2005?
Make the answer very short. 1.09. What is the ratio of the Value added (% of GDP) of Thailand in 2002 to that in 2005?
Your answer should be very brief. 0.95. What is the ratio of the Value added (% of GDP) in Guinea in 2002 to that in 2006?
Provide a succinct answer. 0.98. What is the ratio of the Value added (% of GDP) in Lesotho in 2002 to that in 2006?
Ensure brevity in your answer.  1.28. What is the ratio of the Value added (% of GDP) in Macedonia in 2002 to that in 2006?
Provide a short and direct response. 1.19. What is the ratio of the Value added (% of GDP) in Thailand in 2002 to that in 2006?
Provide a short and direct response. 0.92. What is the ratio of the Value added (% of GDP) in Guinea in 2003 to that in 2004?
Provide a succinct answer. 0.89. What is the ratio of the Value added (% of GDP) of Lesotho in 2003 to that in 2004?
Give a very brief answer. 1.03. What is the ratio of the Value added (% of GDP) in Macedonia in 2003 to that in 2004?
Give a very brief answer. 1. What is the ratio of the Value added (% of GDP) of Thailand in 2003 to that in 2004?
Make the answer very short. 1.02. What is the ratio of the Value added (% of GDP) of Guinea in 2003 to that in 2005?
Your answer should be compact. 0.92. What is the ratio of the Value added (% of GDP) in Lesotho in 2003 to that in 2005?
Give a very brief answer. 1.1. What is the ratio of the Value added (% of GDP) of Macedonia in 2003 to that in 2005?
Ensure brevity in your answer.  1.18. What is the ratio of the Value added (% of GDP) in Thailand in 2003 to that in 2005?
Provide a short and direct response. 1.03. What is the ratio of the Value added (% of GDP) in Guinea in 2003 to that in 2006?
Ensure brevity in your answer.  0.94. What is the ratio of the Value added (% of GDP) of Lesotho in 2003 to that in 2006?
Provide a short and direct response. 1.26. What is the ratio of the Value added (% of GDP) of Macedonia in 2003 to that in 2006?
Offer a very short reply. 1.29. What is the ratio of the Value added (% of GDP) of Guinea in 2004 to that in 2005?
Ensure brevity in your answer.  1.04. What is the ratio of the Value added (% of GDP) of Lesotho in 2004 to that in 2005?
Keep it short and to the point. 1.07. What is the ratio of the Value added (% of GDP) in Macedonia in 2004 to that in 2005?
Make the answer very short. 1.17. What is the ratio of the Value added (% of GDP) of Thailand in 2004 to that in 2005?
Provide a succinct answer. 1.01. What is the ratio of the Value added (% of GDP) in Guinea in 2004 to that in 2006?
Provide a succinct answer. 1.05. What is the ratio of the Value added (% of GDP) in Lesotho in 2004 to that in 2006?
Provide a short and direct response. 1.22. What is the ratio of the Value added (% of GDP) of Macedonia in 2004 to that in 2006?
Your answer should be very brief. 1.29. What is the ratio of the Value added (% of GDP) in Thailand in 2004 to that in 2006?
Ensure brevity in your answer.  0.99. What is the ratio of the Value added (% of GDP) in Guinea in 2005 to that in 2006?
Give a very brief answer. 1.01. What is the ratio of the Value added (% of GDP) of Lesotho in 2005 to that in 2006?
Keep it short and to the point. 1.14. What is the ratio of the Value added (% of GDP) of Macedonia in 2005 to that in 2006?
Ensure brevity in your answer.  1.1. What is the ratio of the Value added (% of GDP) in Thailand in 2005 to that in 2006?
Give a very brief answer. 0.98. What is the difference between the highest and the second highest Value added (% of GDP) of Guinea?
Your answer should be very brief. 0.89. What is the difference between the highest and the second highest Value added (% of GDP) in Lesotho?
Your answer should be very brief. 0.87. What is the difference between the highest and the second highest Value added (% of GDP) in Macedonia?
Give a very brief answer. 0.04. What is the difference between the highest and the second highest Value added (% of GDP) of Thailand?
Keep it short and to the point. 0.04. What is the difference between the highest and the lowest Value added (% of GDP) in Guinea?
Keep it short and to the point. 2.72. What is the difference between the highest and the lowest Value added (% of GDP) of Lesotho?
Keep it short and to the point. 4.96. What is the difference between the highest and the lowest Value added (% of GDP) in Macedonia?
Give a very brief answer. 3.01. What is the difference between the highest and the lowest Value added (% of GDP) of Thailand?
Give a very brief answer. 0.94. 